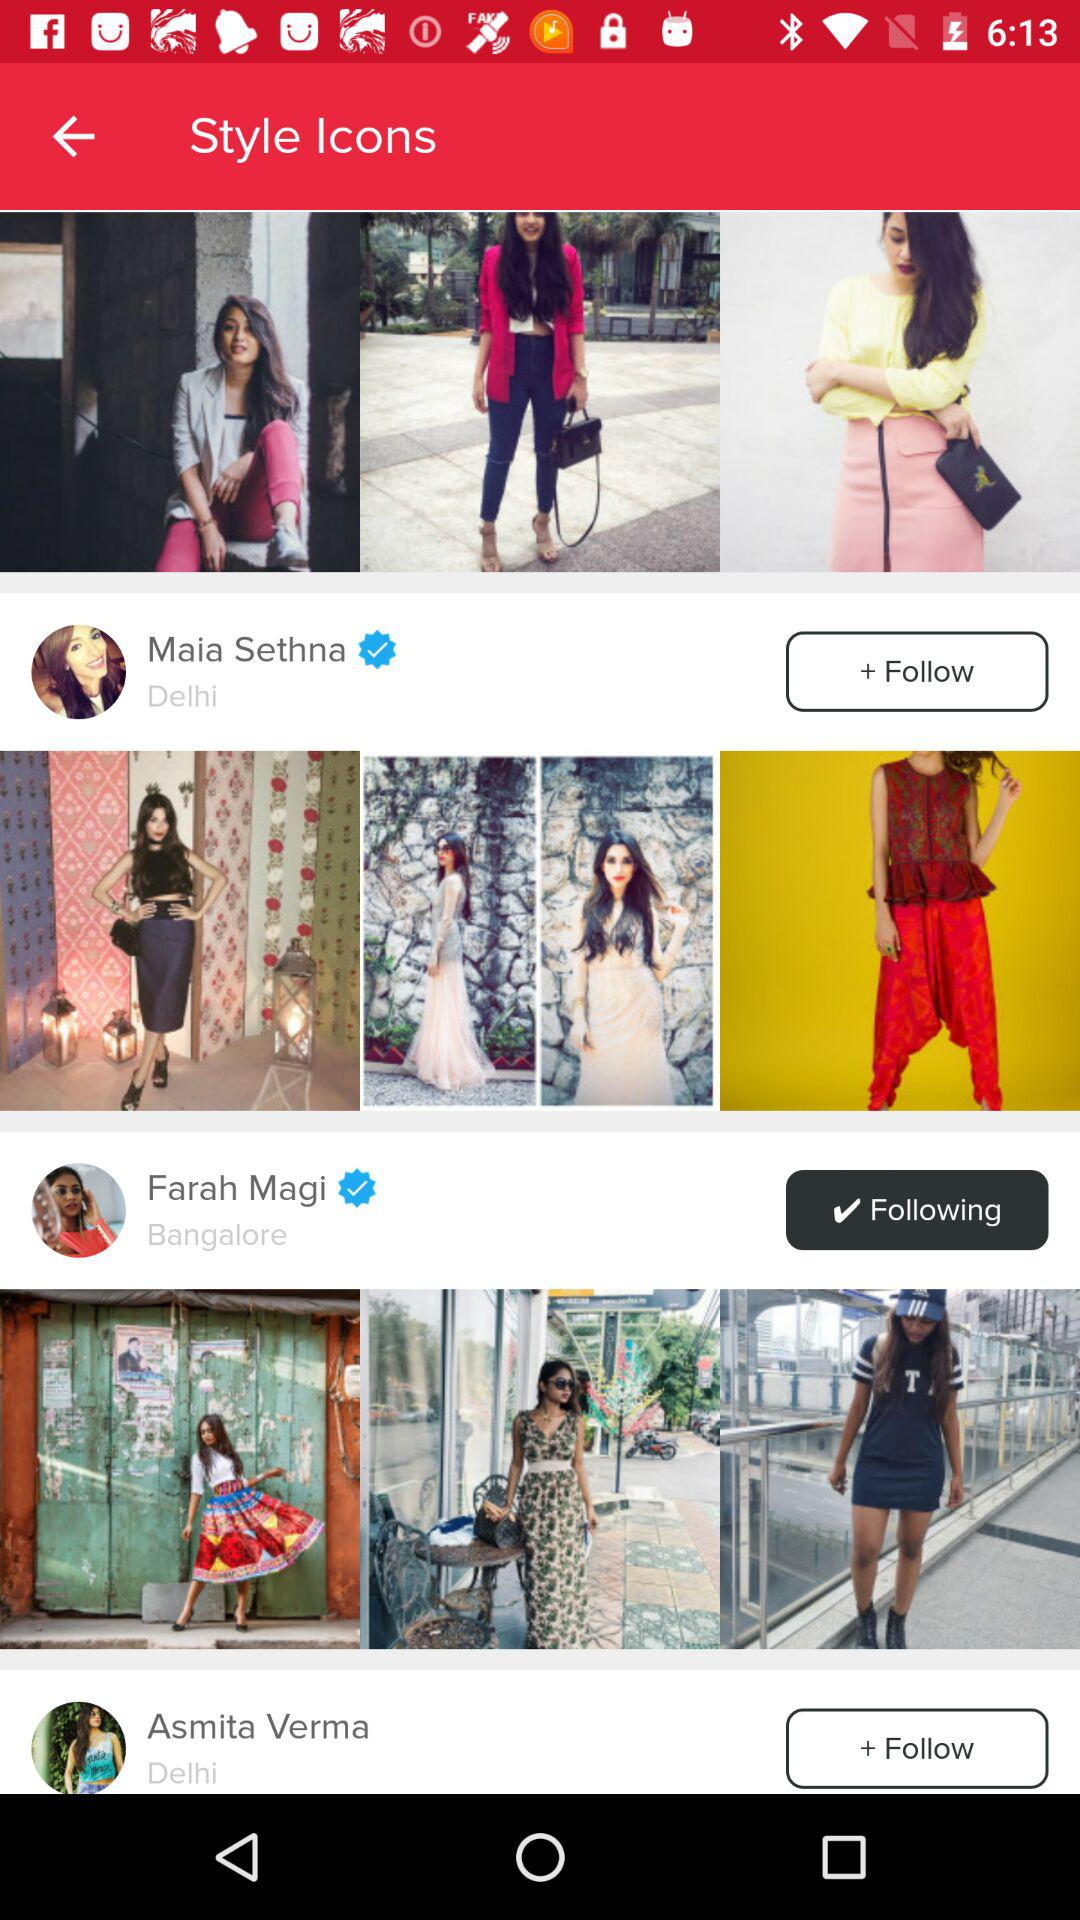Is Farah Magi being followed or not? Farah Magi is being followed. 